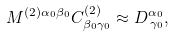Convert formula to latex. <formula><loc_0><loc_0><loc_500><loc_500>M ^ { \left ( 2 \right ) \alpha _ { 0 } \beta _ { 0 } } C _ { \beta _ { 0 } \gamma _ { 0 } } ^ { \left ( 2 \right ) } \approx D _ { \, \gamma _ { 0 } } ^ { \alpha _ { 0 } } ,</formula> 